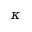Convert formula to latex. <formula><loc_0><loc_0><loc_500><loc_500>\kappa</formula> 